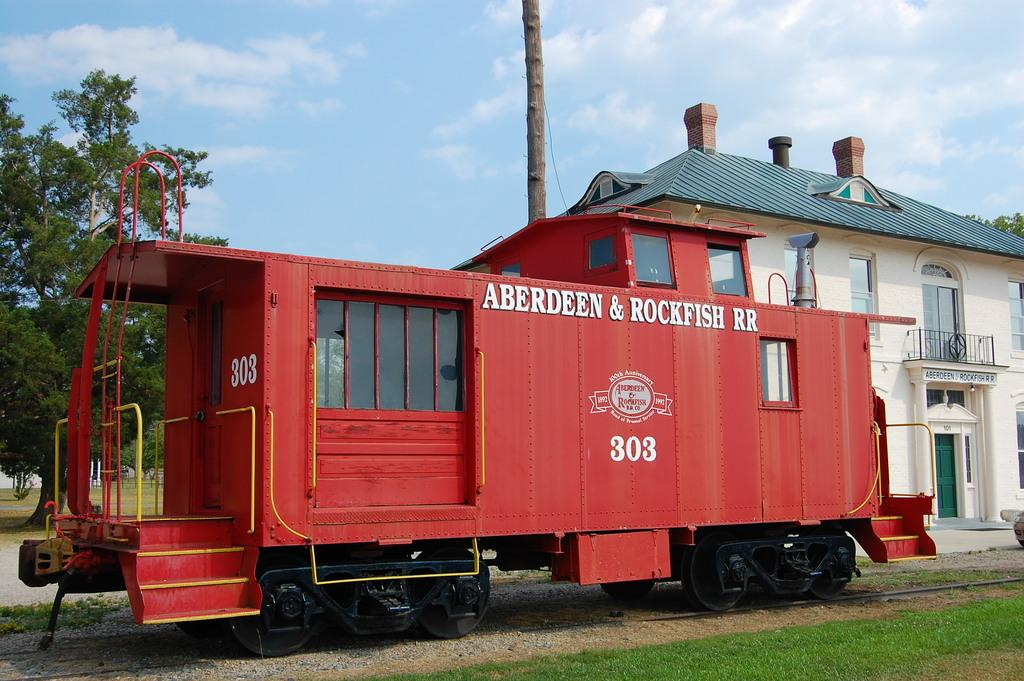What is the main subject of the image? There is a vehicle in the image. What type of environment is depicted in the image? The image shows grass, trees, and a house, suggesting a natural setting. What can be seen in the background of the image? The sky is visible in the background of the image, with clouds present. Can you tell me how many kittens are playing with mint leaves in the image? There are no kittens or mint leaves present in the image. 